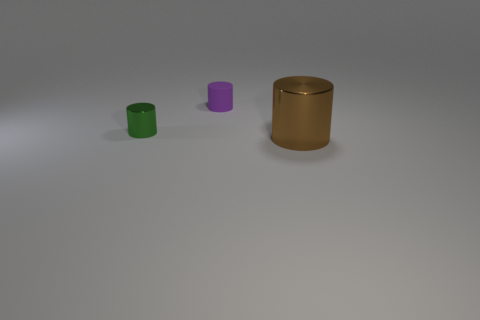Add 1 big yellow balls. How many objects exist? 4 Subtract 0 blue blocks. How many objects are left? 3 Subtract all tiny green metal cylinders. Subtract all yellow rubber spheres. How many objects are left? 2 Add 3 small green shiny objects. How many small green shiny objects are left? 4 Add 3 small blue shiny things. How many small blue shiny things exist? 3 